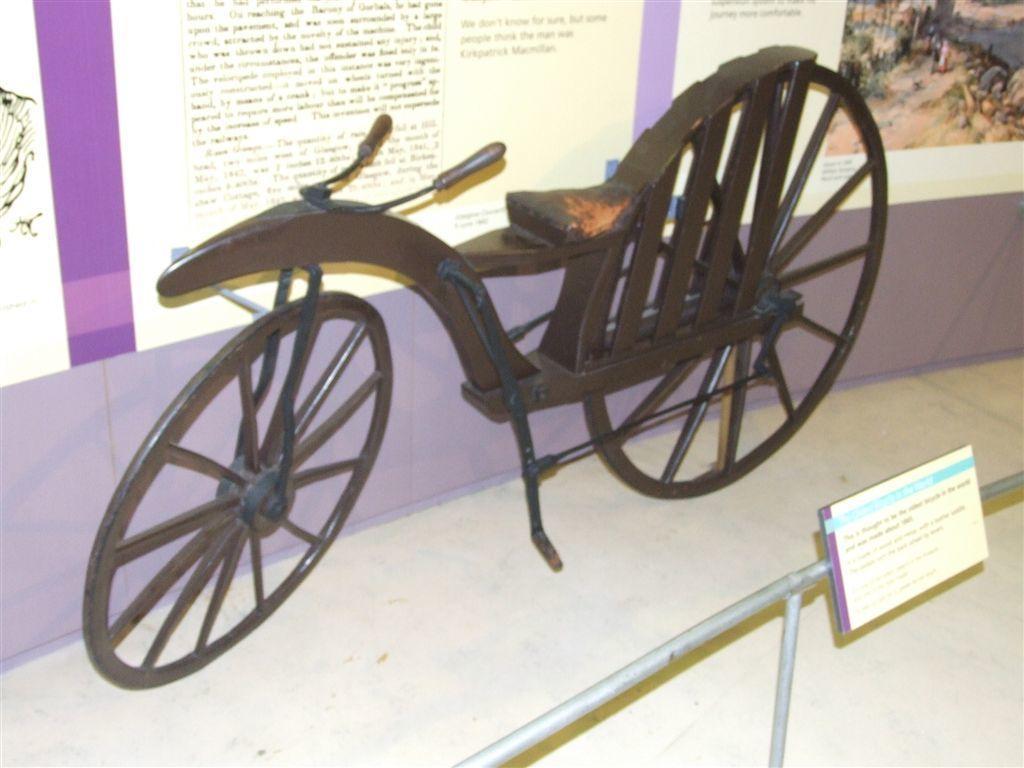In one or two sentences, can you explain what this image depicts? In this image we can see a chaise which is placed on the surface. On the backside we can see some text and pictures on the wall. On the bottom of the image we can see a board to a rod. 